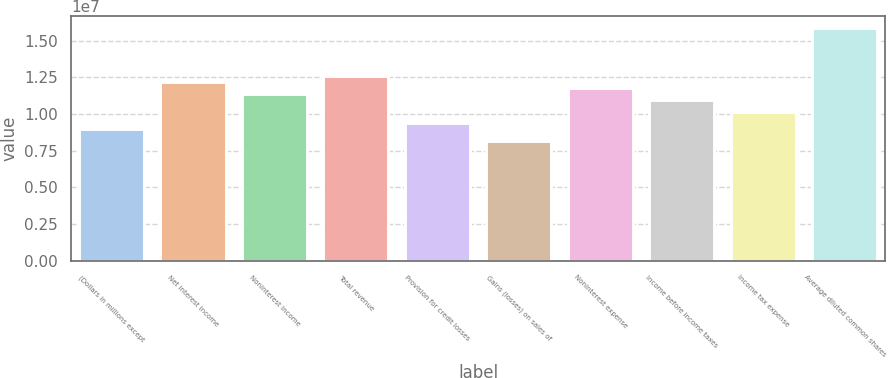Convert chart to OTSL. <chart><loc_0><loc_0><loc_500><loc_500><bar_chart><fcel>(Dollars in millions except<fcel>Net interest income<fcel>Noninterest income<fcel>Total revenue<fcel>Provision for credit losses<fcel>Gains (losses) on sales of<fcel>Noninterest expense<fcel>Income before income taxes<fcel>Income tax expense<fcel>Average diluted common shares<nl><fcel>8.94991e+06<fcel>1.22044e+07<fcel>1.13908e+07<fcel>1.26112e+07<fcel>9.35672e+06<fcel>8.13628e+06<fcel>1.17976e+07<fcel>1.0984e+07<fcel>1.01703e+07<fcel>1.58657e+07<nl></chart> 